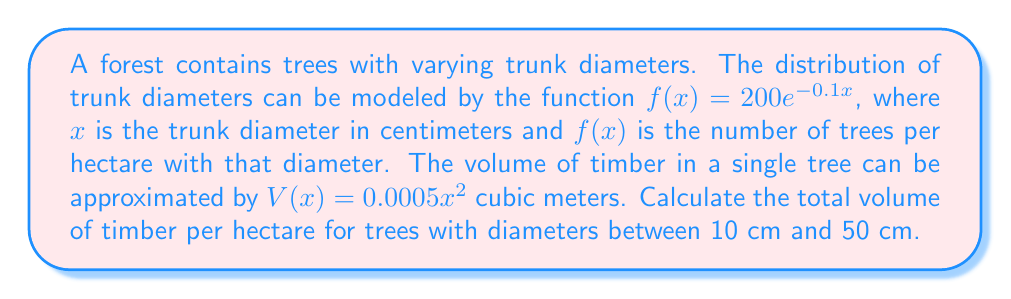Could you help me with this problem? To solve this problem, we need to use an integral equation. Here's the step-by-step approach:

1) The total volume of timber is the sum of the volumes of all trees within the given diameter range. This can be represented as an integral:

   $$\text{Total Volume} = \int_{10}^{50} V(x)f(x) dx$$

2) Substitute the given functions:

   $$\text{Total Volume} = \int_{10}^{50} (0.0005x^2)(200e^{-0.1x}) dx$$

3) Simplify the integrand:

   $$\text{Total Volume} = 0.1 \int_{10}^{50} x^2e^{-0.1x} dx$$

4) This integral doesn't have an elementary antiderivative. We can solve it using integration by parts twice:

   Let $u = x^2$ and $dv = e^{-0.1x}dx$
   Then $du = 2x dx$ and $v = -10e^{-0.1x}$

   $$\begin{align}
   \int x^2e^{-0.1x} dx &= -10x^2e^{-0.1x} - \int(-10)(2x)e^{-0.1x} dx \\
   &= -10x^2e^{-0.1x} + 20\int xe^{-0.1x} dx
   \end{align}$$

   Now for the remaining integral, let $u = x$ and $dv = e^{-0.1x}dx$
   Then $du = dx$ and $v = -10e^{-0.1x}$

   $$\begin{align}
   \int xe^{-0.1x} dx &= -10xe^{-0.1x} - \int(-10)e^{-0.1x} dx \\
   &= -10xe^{-0.1x} + 100e^{-0.1x}
   \end{align}$$

5) Putting it all together:

   $$\int x^2e^{-0.1x} dx = -10x^2e^{-0.1x} + 20(-10xe^{-0.1x} + 100e^{-0.1x}) + C$$
   $$= -10x^2e^{-0.1x} - 200xe^{-0.1x} + 2000e^{-0.1x} + C$$

6) Now we can evaluate the definite integral:

   $$\text{Total Volume} = 0.1 \left[-10x^2e^{-0.1x} - 200xe^{-0.1x} + 2000e^{-0.1x}\right]_{10}^{50}$$

7) Evaluate at the limits and subtract:

   $$\begin{align}
   \text{Total Volume} &= 0.1 \left[(-25000e^{-5} - 10000e^{-5} + 2000e^{-5}) - (-1000e^{-1} - 2000e^{-1} + 2000e^{-1})\right] \\
   &= 0.1 \left[-33000e^{-5} + 1000e^{-1}\right] \\
   &\approx 36.90 \text{ cubic meters per hectare}
   \end{align}$$
Answer: 36.90 m³/ha 